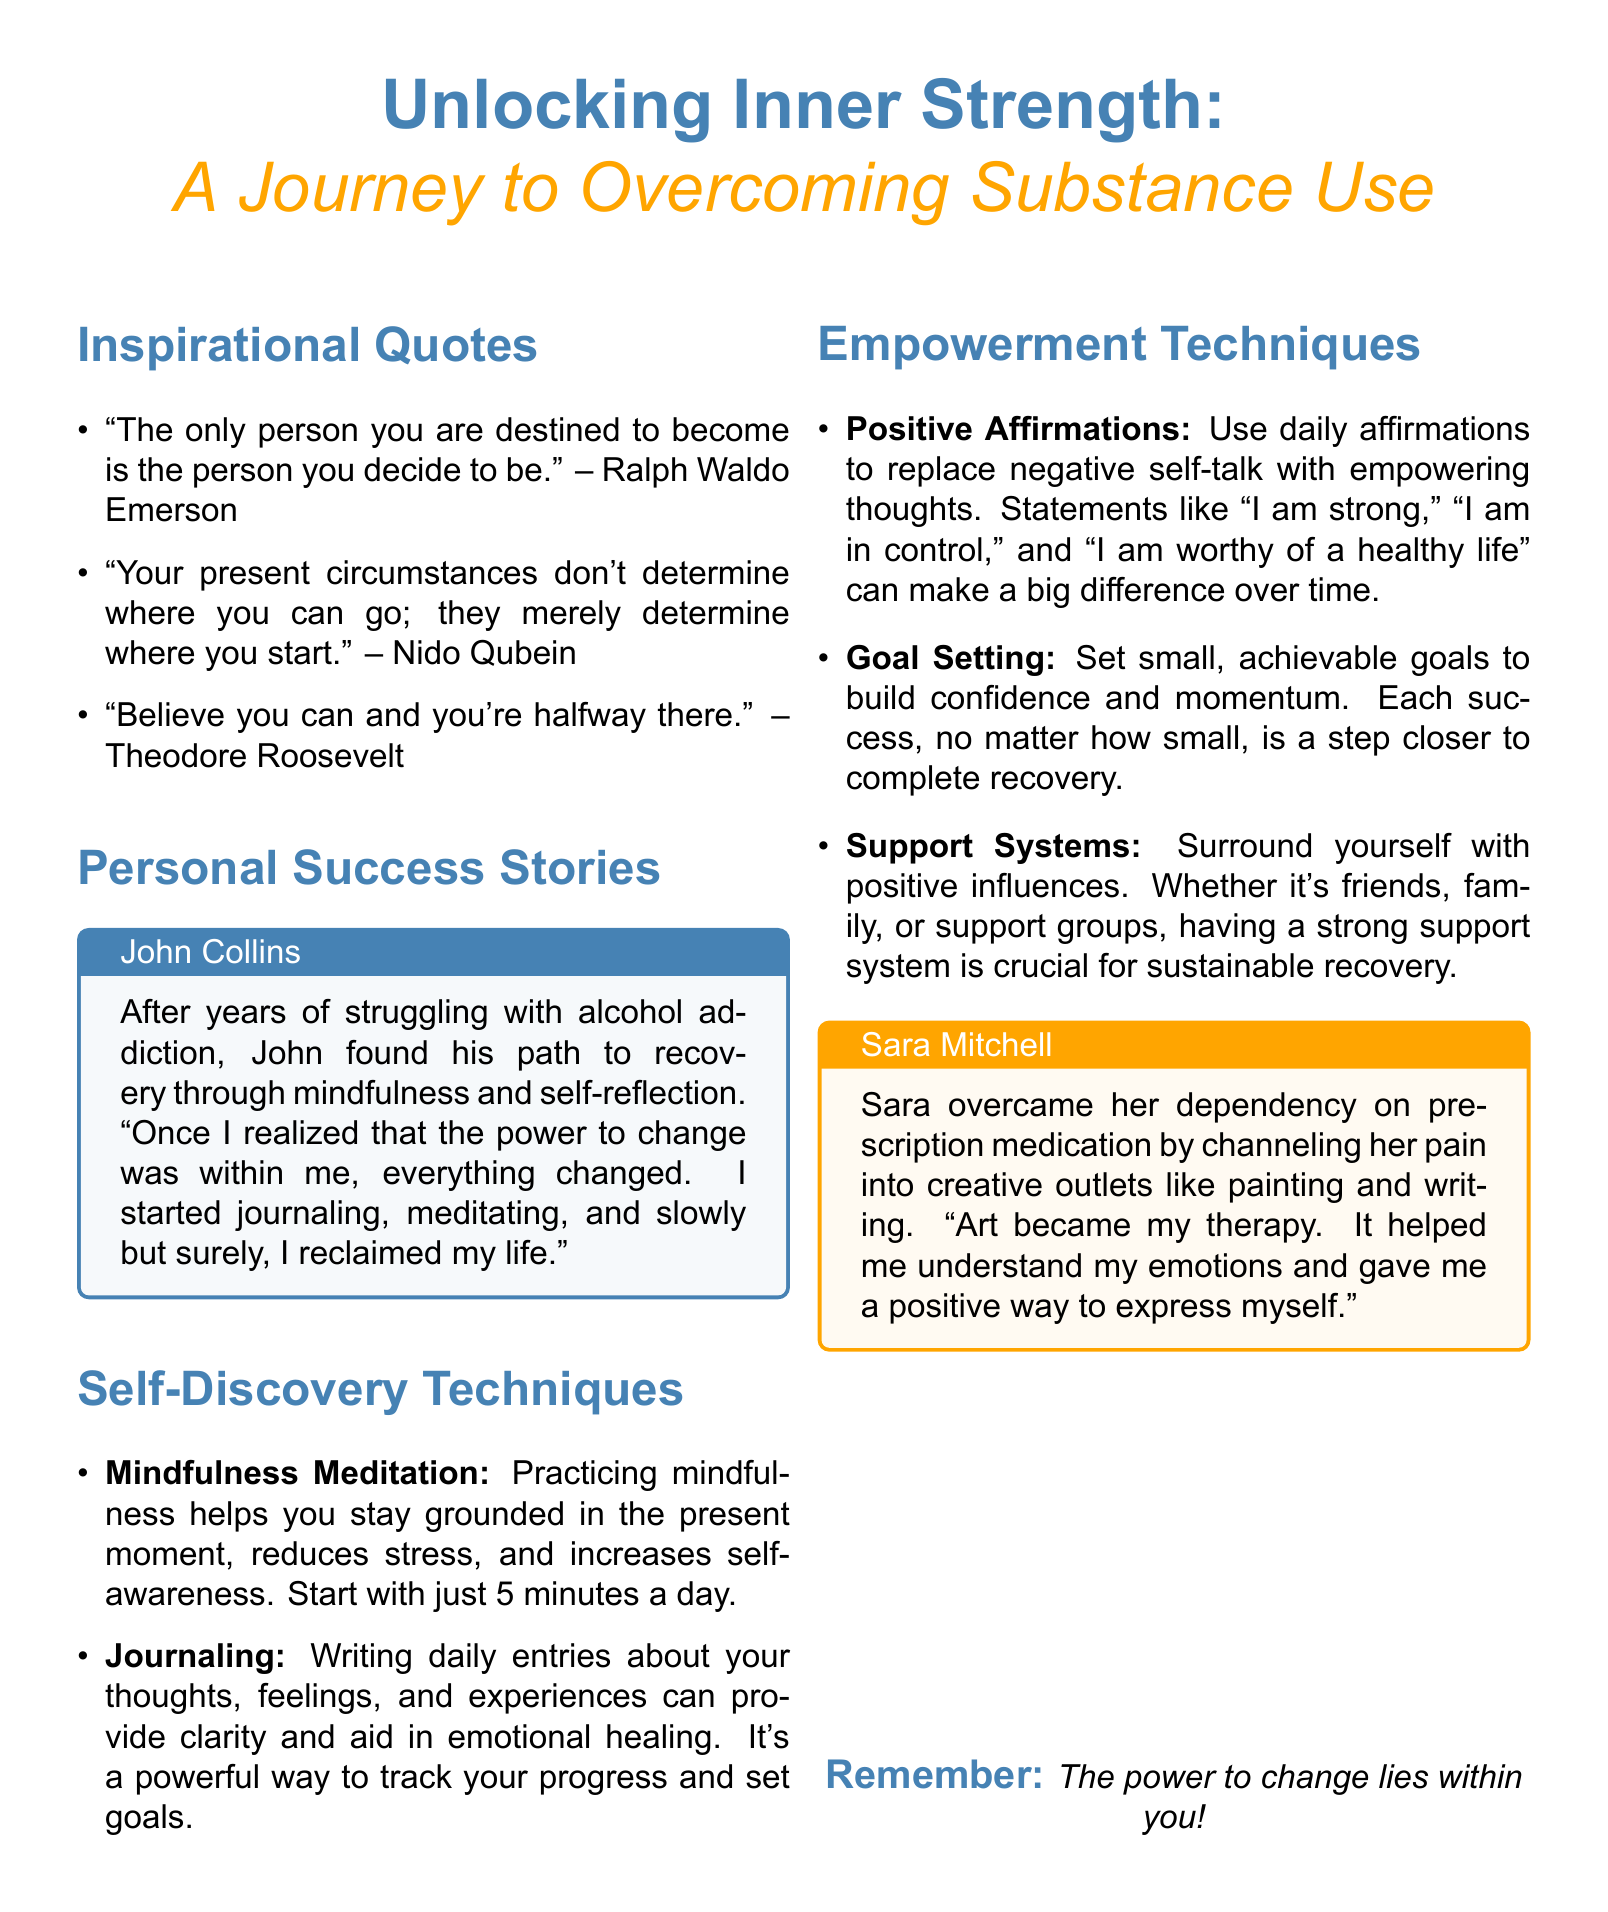What is the title of the flyer? The title of the flyer is located at the top of the document, presenting the main theme.
Answer: Unlocking Inner Strength Who shares their personal success story in the flyer? The document includes personal success stories of individuals, specifically mentioning their names with details.
Answer: John Collins What is one self-discovery technique mentioned? The flyer outlines various self-discovery techniques that promote personal growth and recovery.
Answer: Mindfulness Meditation What color is associated with the inspirational quotes section? Each section of the flyer is color-coded, with specific colors representing different elements.
Answer: Main color How did Sara Mitchell overcome her dependency? The flyer describes ways in which individuals have succeeded in overcoming substance use, highlighting specific activities.
Answer: Creative outlets What is one empowerment technique listed in the flyer? The document provides techniques designed to empower individuals on their recovery journey.
Answer: Positive Affirmations 